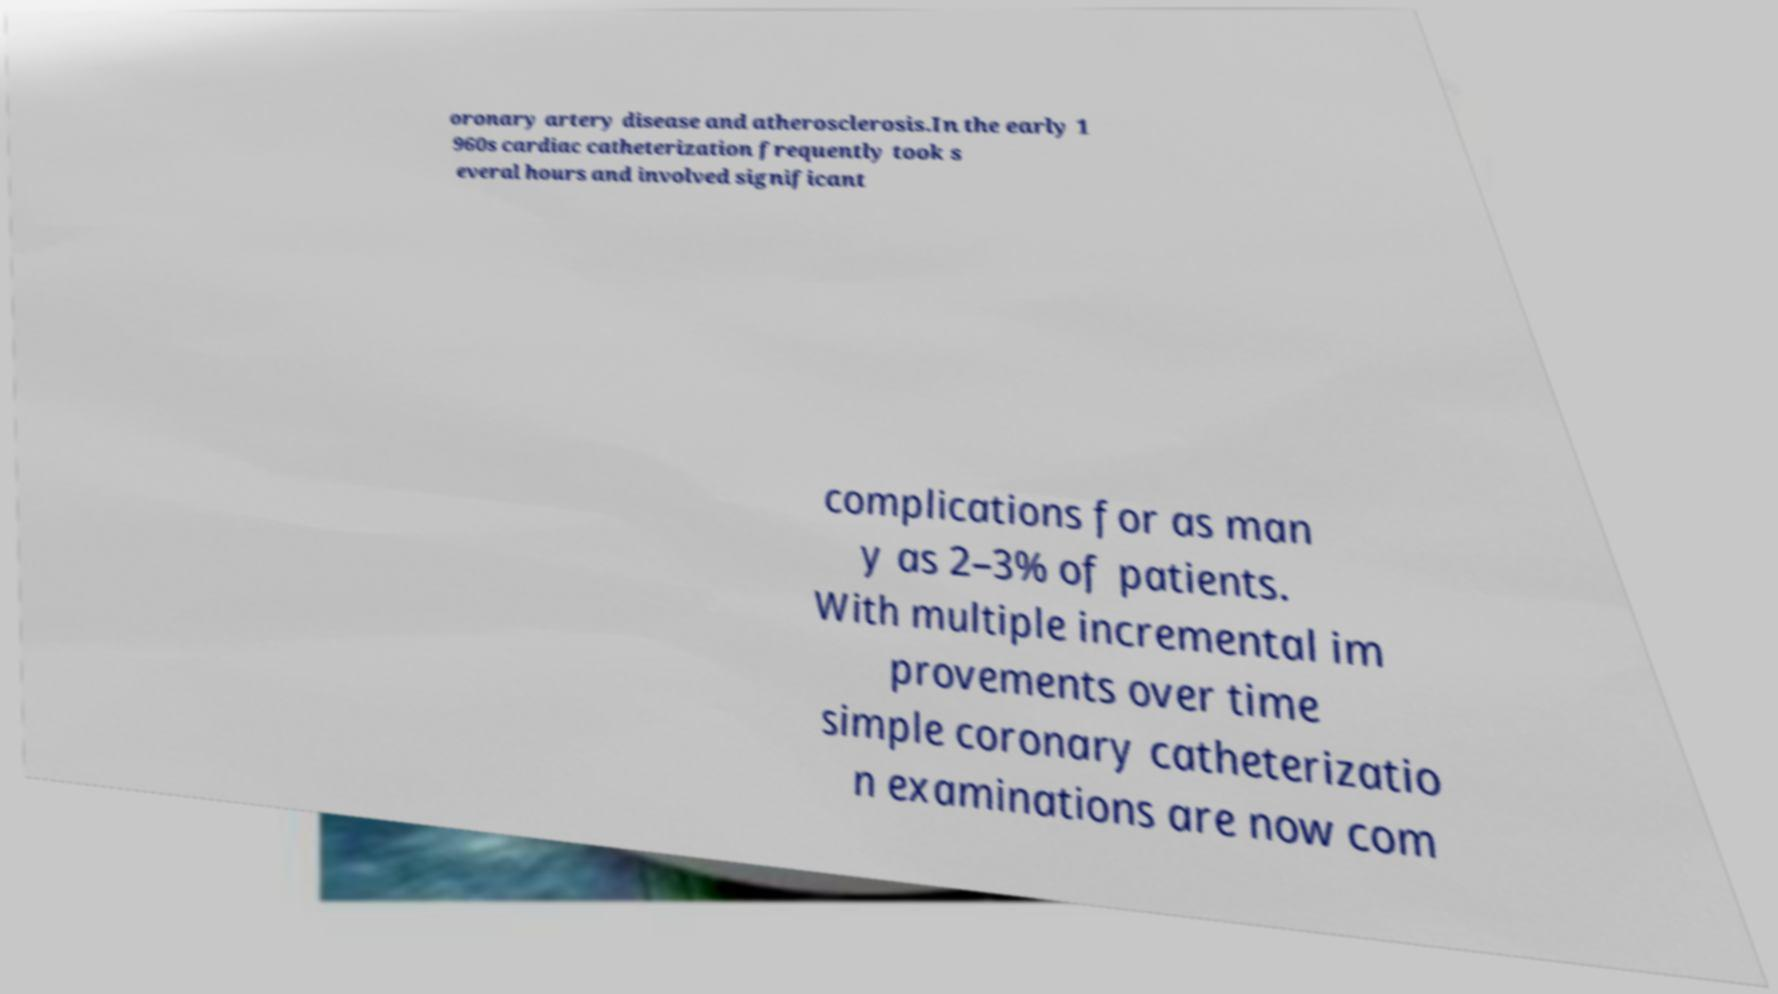What messages or text are displayed in this image? I need them in a readable, typed format. oronary artery disease and atherosclerosis.In the early 1 960s cardiac catheterization frequently took s everal hours and involved significant complications for as man y as 2–3% of patients. With multiple incremental im provements over time simple coronary catheterizatio n examinations are now com 